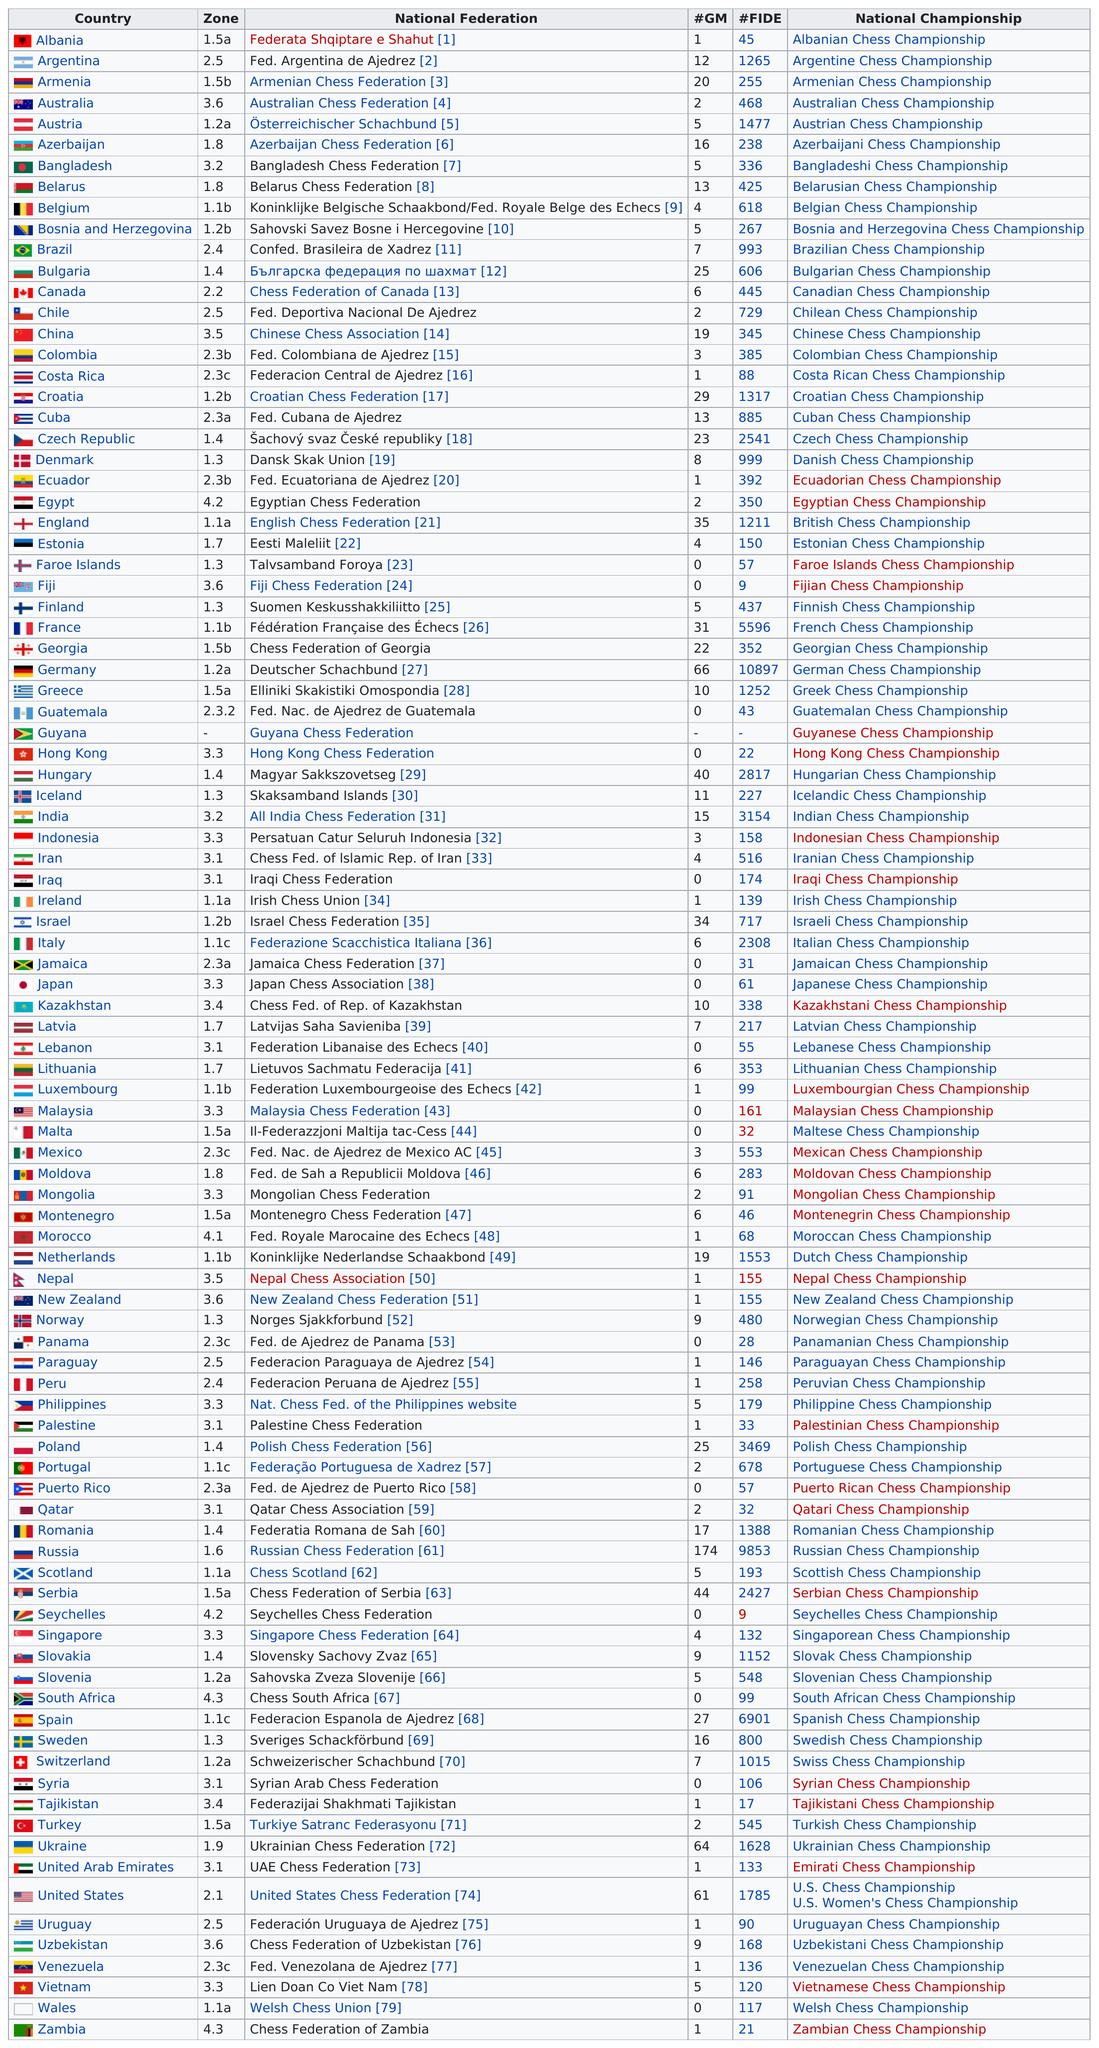List a handful of essential elements in this visual. Russia has the most grandmasters, making it the country with the highest number of chess masters. Russia has the most number of GMs. The number of grandmasters Bulgaria has listed is 25. Bangladesh is located in Zone 3.2 along with India or in Zone 3.5 along with China, depending on the source. Russia has the greatest number of FIDE rated players after Germany. 